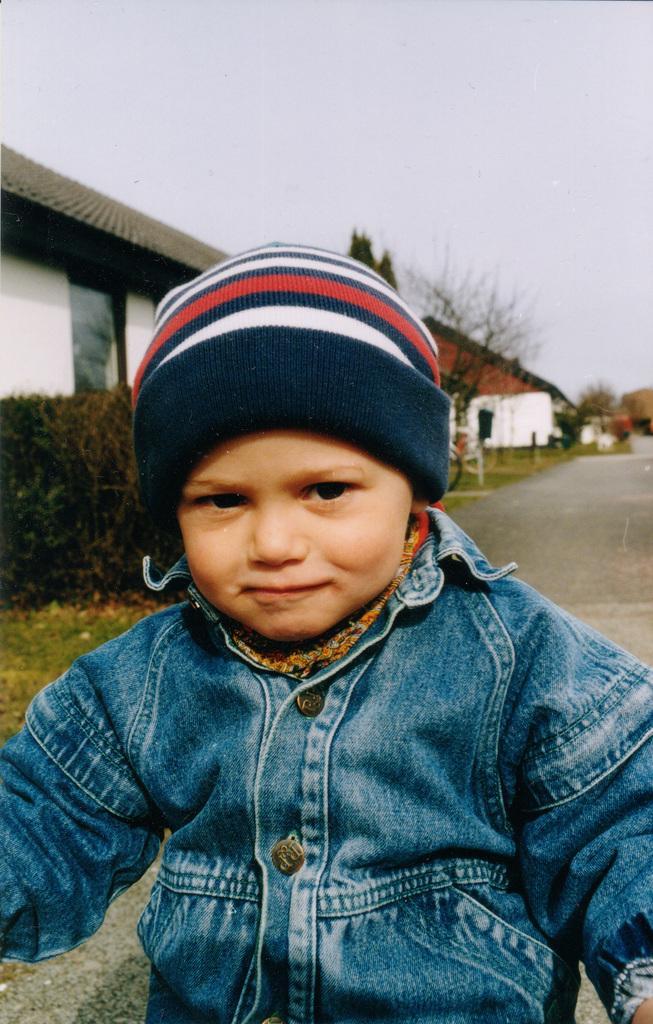In one or two sentences, can you explain what this image depicts? In this image in front there is a boy. In the background of the image there are houses, road, trees and sky. 